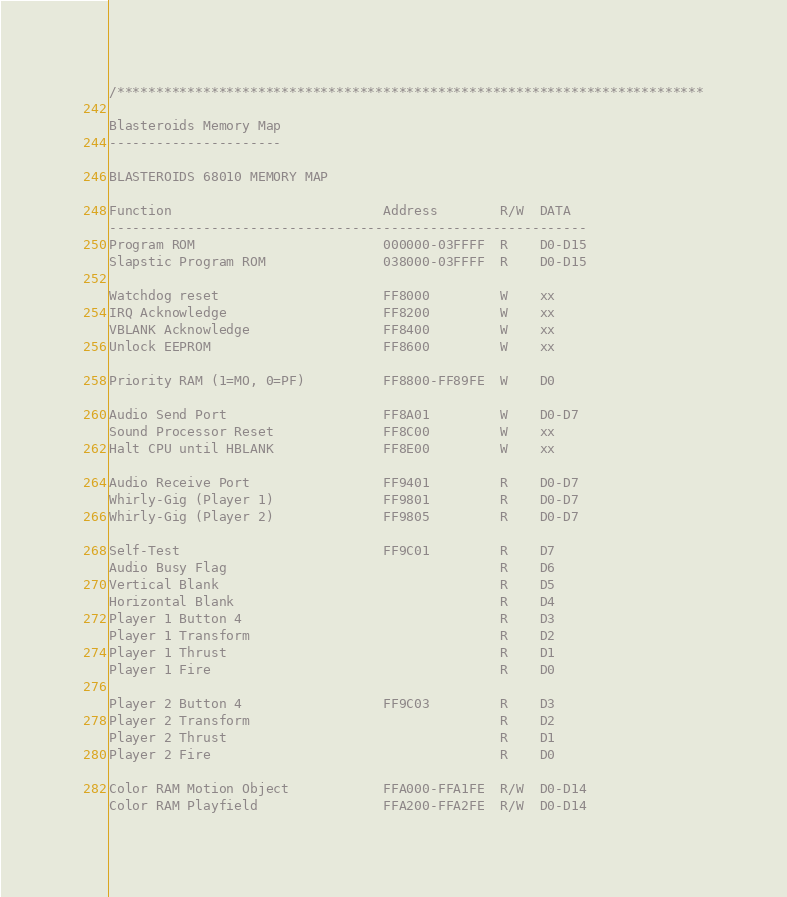<code> <loc_0><loc_0><loc_500><loc_500><_C++_>/***************************************************************************

Blasteroids Memory Map
----------------------

BLASTEROIDS 68010 MEMORY MAP

Function                           Address        R/W  DATA
-------------------------------------------------------------
Program ROM                        000000-03FFFF  R    D0-D15
Slapstic Program ROM               038000-03FFFF  R    D0-D15

Watchdog reset                     FF8000         W    xx
IRQ Acknowledge                    FF8200         W    xx
VBLANK Acknowledge                 FF8400         W    xx
Unlock EEPROM                      FF8600         W    xx

Priority RAM (1=MO, 0=PF)          FF8800-FF89FE  W    D0

Audio Send Port                    FF8A01         W    D0-D7
Sound Processor Reset              FF8C00         W    xx
Halt CPU until HBLANK              FF8E00         W    xx

Audio Receive Port                 FF9401         R    D0-D7
Whirly-Gig (Player 1)              FF9801         R    D0-D7
Whirly-Gig (Player 2)              FF9805         R    D0-D7

Self-Test                          FF9C01         R    D7
Audio Busy Flag                                   R    D6
Vertical Blank                                    R    D5
Horizontal Blank                                  R    D4
Player 1 Button 4                                 R    D3
Player 1 Transform                                R    D2
Player 1 Thrust                                   R    D1
Player 1 Fire                                     R    D0

Player 2 Button 4                  FF9C03         R    D3
Player 2 Transform                                R    D2
Player 2 Thrust                                   R    D1
Player 2 Fire                                     R    D0

Color RAM Motion Object            FFA000-FFA1FE  R/W  D0-D14
Color RAM Playfield                FFA200-FFA2FE  R/W  D0-D14
</code> 